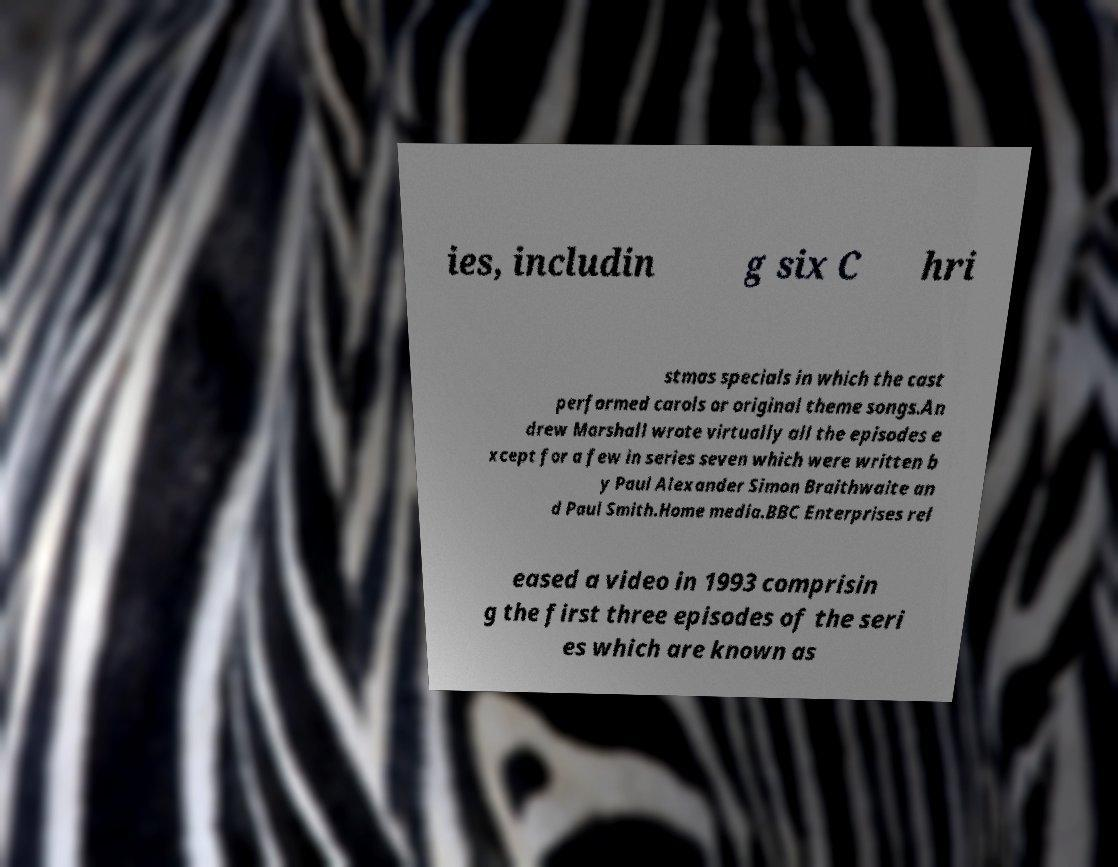Can you accurately transcribe the text from the provided image for me? ies, includin g six C hri stmas specials in which the cast performed carols or original theme songs.An drew Marshall wrote virtually all the episodes e xcept for a few in series seven which were written b y Paul Alexander Simon Braithwaite an d Paul Smith.Home media.BBC Enterprises rel eased a video in 1993 comprisin g the first three episodes of the seri es which are known as 